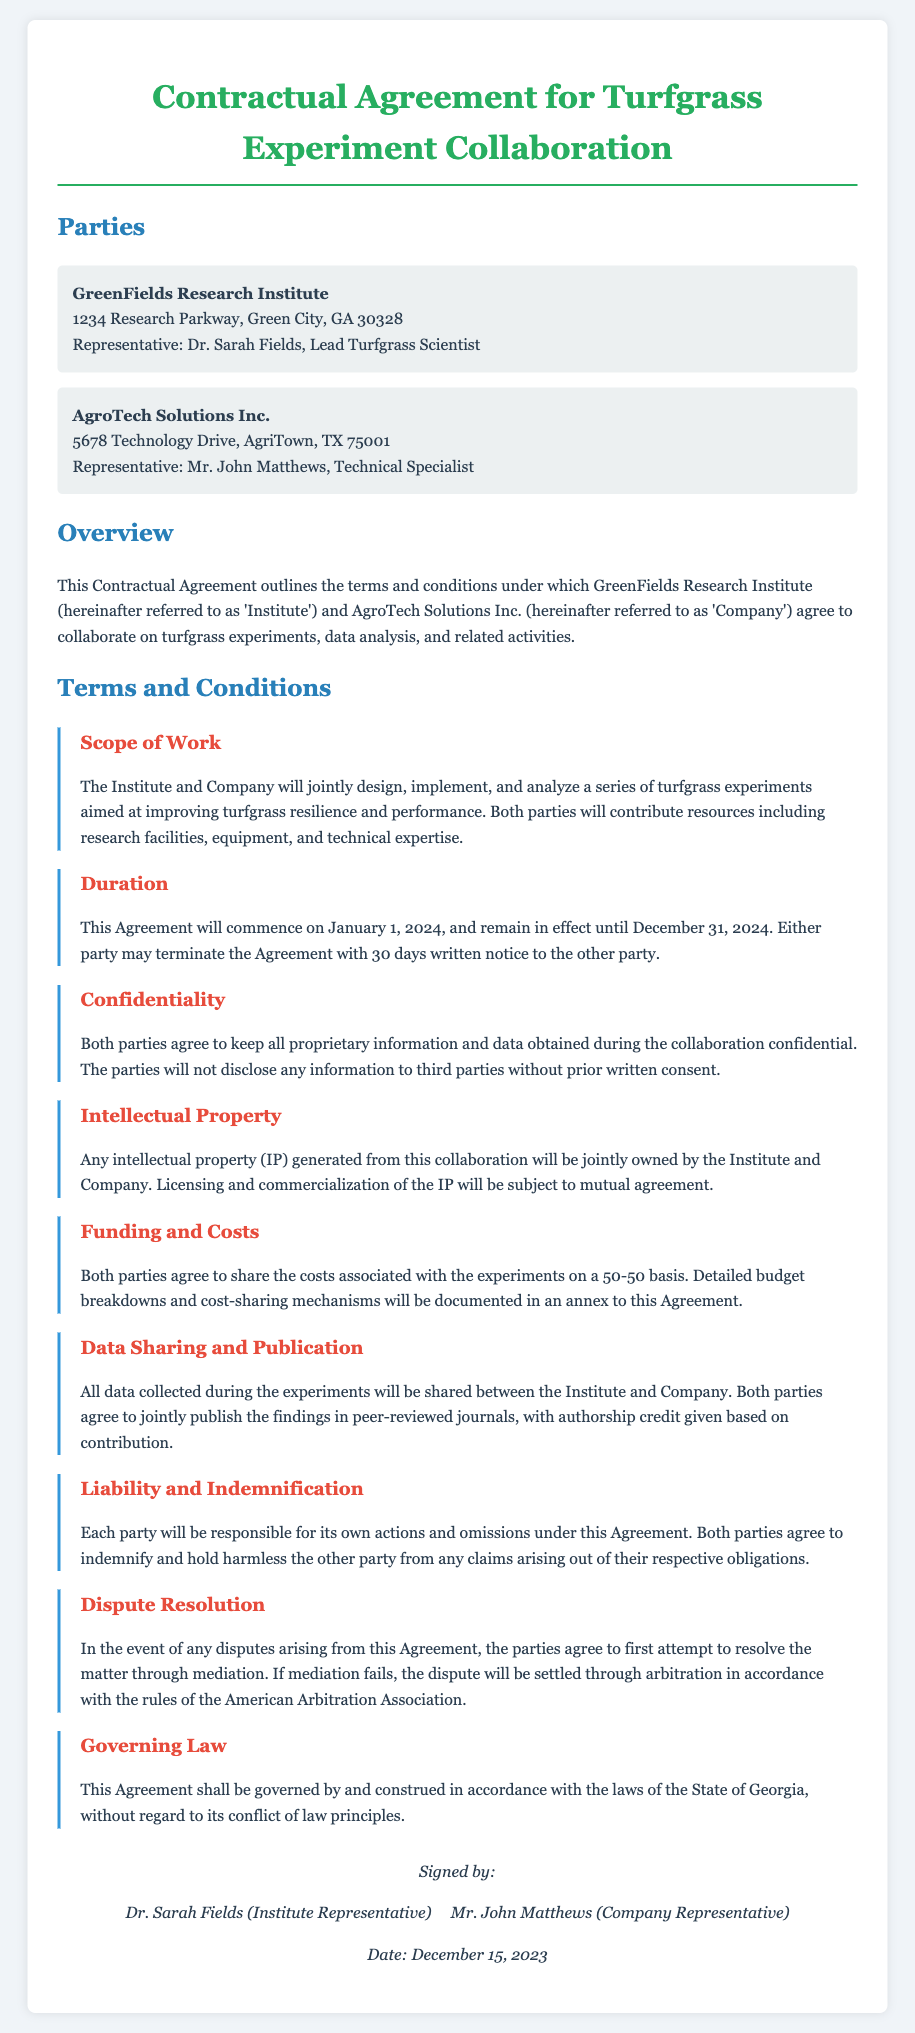What is the name of the Institute? The name of the Institute is stated in the introduction of the document as GreenFields Research Institute.
Answer: GreenFields Research Institute Who is the representative of AgroTech Solutions Inc.? The representative's name is mentioned under the party’s section for AgroTech Solutions Inc.
Answer: Mr. John Matthews What is the duration of the agreement? The duration of the agreement is specified in the terms and conditions section regarding the agreement's duration.
Answer: January 1, 2024 to December 31, 2024 What is the cost-sharing mechanism outlined in the agreement? The agreement specifies how the costs will be shared between both parties in the terms regarding funding and costs.
Answer: 50-50 basis What must parties do in case of disputes? The document outlines the process for handling disputes, emphasizing mediation first.
Answer: Mediation What will happen to intellectual property generated from the collaboration? The agreement specifies the ownership of intellectual property generated between the two parties.
Answer: Jointly owned How long is the notice period for termination of the agreement? The notice period for termination is mentioned in the terms and conditions section on duration.
Answer: 30 days What is the governing law for this agreement? The governing law for the agreement is stated towards the end of the document.
Answer: State of Georgia Who signed the agreement? The signatories are noted at the end of the document where the signatures are located.
Answer: Dr. Sarah Fields & Mr. John Matthews 